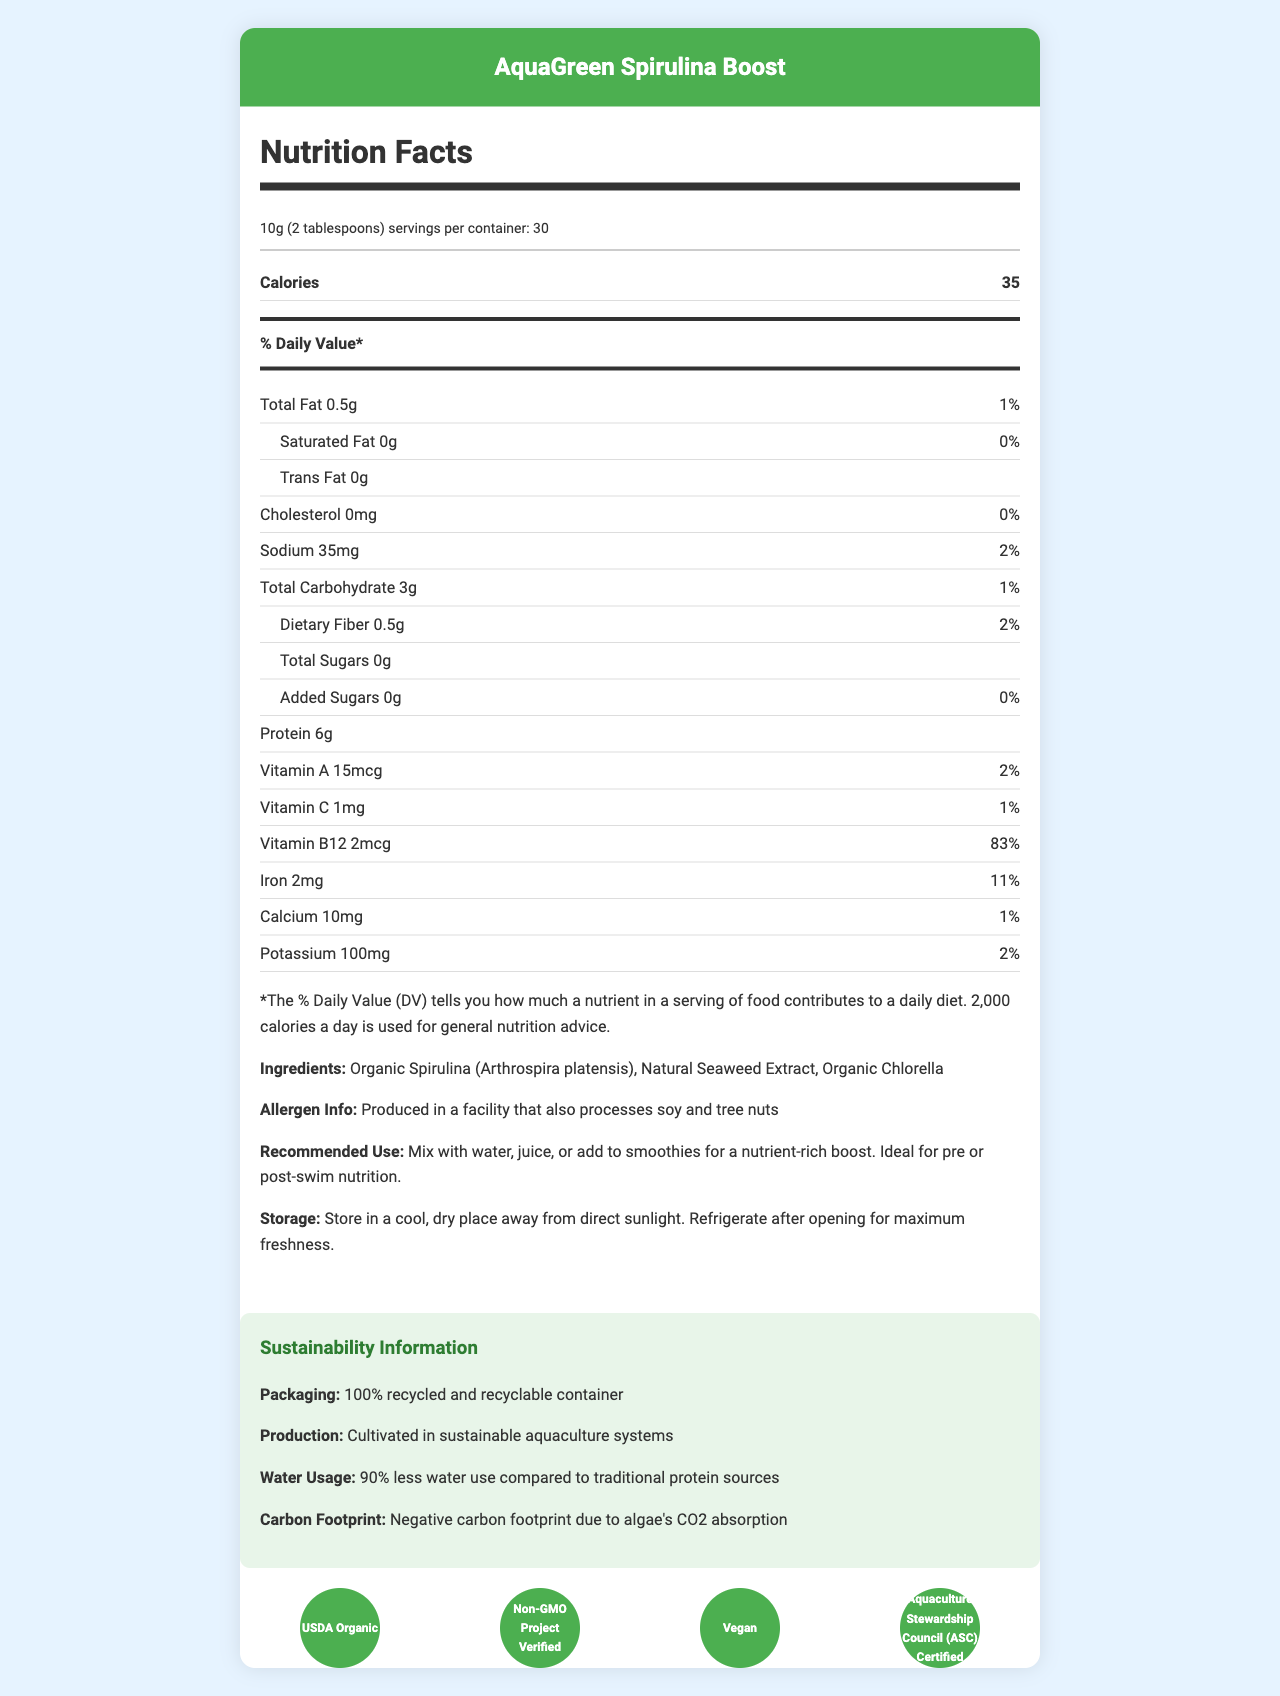what is the serving size? The serving size is explicitly stated at the beginning of the nutrition information.
Answer: 10g (2 tablespoons) how many calories are in one serving of AquaGreen Spirulina Boost? The calorie count per serving is clearly listed under the nutrition facts.
Answer: 35 what are the main ingredients? The ingredients are listed towards the end of the nutrition facts section.
Answer: Organic Spirulina, Natural Seaweed Extract, Organic Chlorella what certifications does the product have? The certifications section provides this information, displayed graphically and in text form.
Answer: USDA Organic, Non-GMO Project Verified, Vegan, Aquaculture Stewardship Council (ASC) Certified what is the recommended use of AquaGreen Spirulina Boost? The recommended use is given towards the end, detailing how the product can be utilized.
Answer: Mix with water, juice, or add to smoothies for a nutrient-rich boost. Ideal for pre or post-swim nutrition. how much protein does one serving contain? The protein content per serving is listed under the nutrition facts.
Answer: 6g what percentage of the daily value for Vitamin B12 does one serving provide? The % daily value of Vitamin B12 is clearly listed in the nutrition facts.
Answer: 83% which nutrient has the highest daily value percentage? A. Vitamin A B. Iron C. Vitamin B12 D. Calcium The % daily value for each nutrient is provided, with Vitamin B12 being the highest at 83%.
Answer: C. Vitamin B12 what is the cholesterol content of AquaGreen Spirulina Boost? The cholesterol content is clearly listed in the nutrition facts.
Answer: 0mg how should the product be stored after opening? The storage instruction advises refrigeration after opening, as stated.
Answer: Refrigerate after opening for maximum freshness. true or false: AquaGreen Spirulina Boost contains added sugars. The nutrition facts clearly state that there are 0g of added sugars.
Answer: False what is the carbon footprint of the product's production described as? The sustainability section mentions that the production of AquaGreen Spirulina Boost has a negative carbon footprint.
Answer: Negative carbon footprint due to algae's CO2 absorption how many servings are there per container? The number of servings per container is provided at the top of the nutrition facts.
Answer: 30 what is the sodium content per serving? The sodium content per serving is listed under the nutrition facts.
Answer: 35mg how should the document be described to someone unfamiliar with it? The document is an informative layout combining nutrition, usage, and environmental sustainability of AquaGreen Spirulina Boost, helpful for guiding the implementation of sustainable practices in an aquatic facility cafeteria.
Answer: The document provides detailed nutrition facts and sustainability information for AquaGreen Spirulina Boost, an algae-based food supplement. It includes serving size, calorie count, macronutrients, vitamins, and minerals along with ingredients, allergen information, recommended use, and storage instructions. There’s also a sustainability section highlighting packaging, production, water usage, and carbon footprint, and a list of product certifications. how much fiber is in each serving? The document does not provide explicit information about the total fiber content per serving.
Answer: Not enough information 